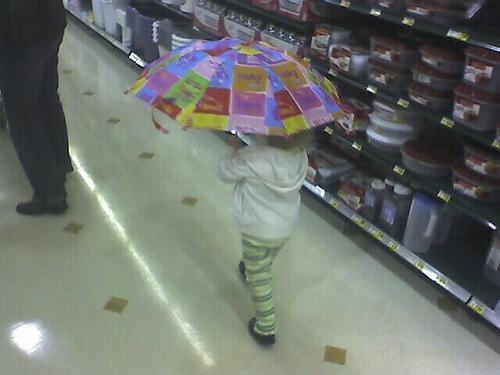How many people are there?
Give a very brief answer. 2. 